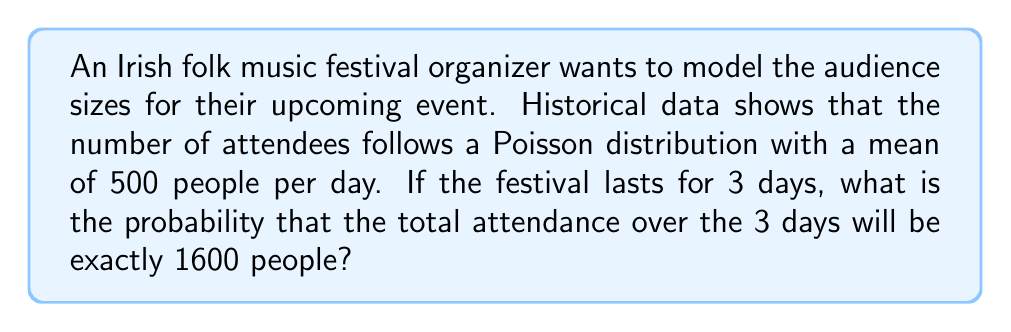Could you help me with this problem? Let's approach this step-by-step:

1) First, we need to understand that the total attendance over 3 days is the sum of three independent Poisson random variables, each representing one day's attendance.

2) The sum of independent Poisson random variables is also a Poisson random variable. The mean of this new Poisson distribution is the sum of the means of the individual distributions.

3) So, for 3 days, the mean of the total attendance distribution is:
   $$ \lambda_{total} = 3 \times 500 = 1500 $$

4) Now, we have a Poisson distribution with mean 1500, and we want to find the probability of exactly 1600 attendees.

5) The probability mass function for a Poisson distribution is:
   $$ P(X = k) = \frac{e^{-\lambda} \lambda^k}{k!} $$

6) Substituting our values:
   $$ P(X = 1600) = \frac{e^{-1500} 1500^{1600}}{1600!} $$

7) This can be calculated using a calculator or computer software:
   $$ P(X = 1600) \approx 0.010307 $$
Answer: $0.010307$ or approximately $1.03\%$ 